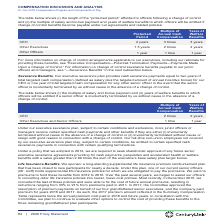According to Centurylink's financial document, What does 'Protected Period' in the table refer to? “protected period” afforded to officers following a change of control. The document states: "The table below shows (i) the length of the “protected period” afforded to officers following a change of control and (ii) the multiple of salary and ..." Also, Under what conditions would officers be entitled to the years of welfare benefits? if change of control benefits become payable under our agreements and related policies. The document states: "lfare benefits to which officers will be entitled if change of control benefits become payable under our agreements and related policies:..." Also, Which types of officers are listed in the table? The document contains multiple relevant values: CEO, Other Executives, Other Officers. From the document: "Other Executives 1.5 years 2 times 2 years CEO 2 years 3 times 3 years Other Officers 1 year 1 time 1 year..." Additionally, Which type of officer has the longest protected period? According to the financial document, CEO. The relevant text states: "CEO 2 years 3 times 3 years..." Also, can you calculate: What is the difference in the protected period between CEO and Other Executives? Based on the calculation: 2-1.5, the result is 0.5. This is based on the information: "Other Executives 1.5 years 2 times 2 years Other Executives 1.5 years 2 times 2 years..." The key data points involved are: 1.5, 2. Also, can you calculate: What is the average protected period? To answer this question, I need to perform calculations using the financial data. The calculation is: (2+1.5+1)/3, which equals 1.5. This is based on the information: "Other Executives 1.5 years 2 times 2 years Other Executives 1.5 years 2 times 2 years Other Executives 1.5 years 2 times 2 years..." The key data points involved are: 2. 